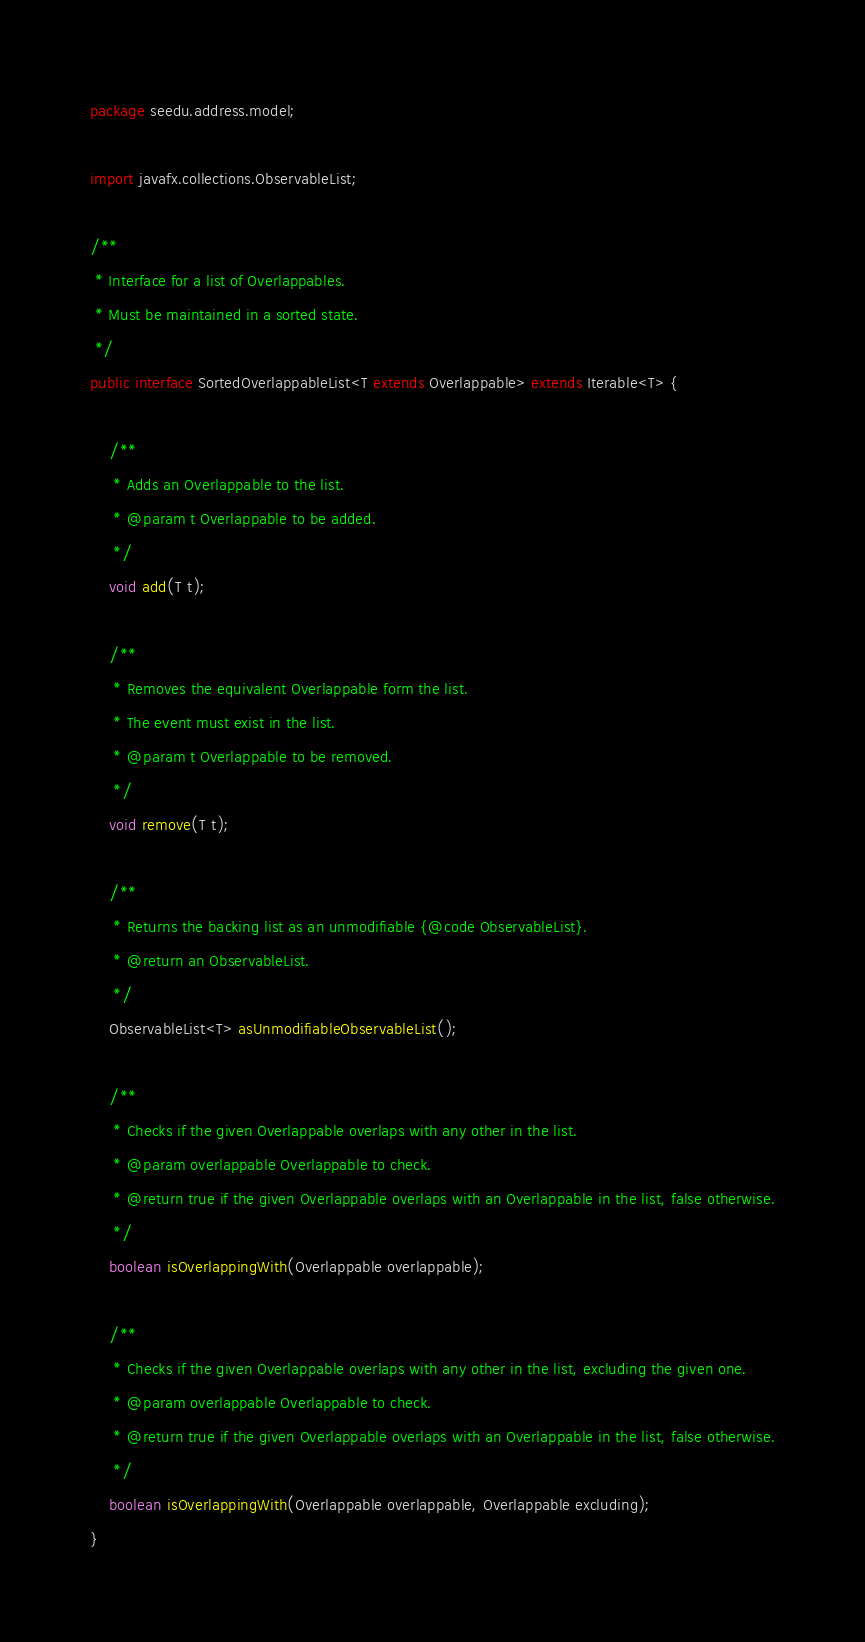<code> <loc_0><loc_0><loc_500><loc_500><_Java_>package seedu.address.model;

import javafx.collections.ObservableList;

/**
 * Interface for a list of Overlappables.
 * Must be maintained in a sorted state.
 */
public interface SortedOverlappableList<T extends Overlappable> extends Iterable<T> {

    /**
     * Adds an Overlappable to the list.
     * @param t Overlappable to be added.
     */
    void add(T t);

    /**
     * Removes the equivalent Overlappable form the list.
     * The event must exist in the list.
     * @param t Overlappable to be removed.
     */
    void remove(T t);

    /**
     * Returns the backing list as an unmodifiable {@code ObservableList}.
     * @return an ObservableList.
     */
    ObservableList<T> asUnmodifiableObservableList();

    /**
     * Checks if the given Overlappable overlaps with any other in the list.
     * @param overlappable Overlappable to check.
     * @return true if the given Overlappable overlaps with an Overlappable in the list, false otherwise.
     */
    boolean isOverlappingWith(Overlappable overlappable);

    /**
     * Checks if the given Overlappable overlaps with any other in the list, excluding the given one.
     * @param overlappable Overlappable to check.
     * @return true if the given Overlappable overlaps with an Overlappable in the list, false otherwise.
     */
    boolean isOverlappingWith(Overlappable overlappable, Overlappable excluding);
}
</code> 